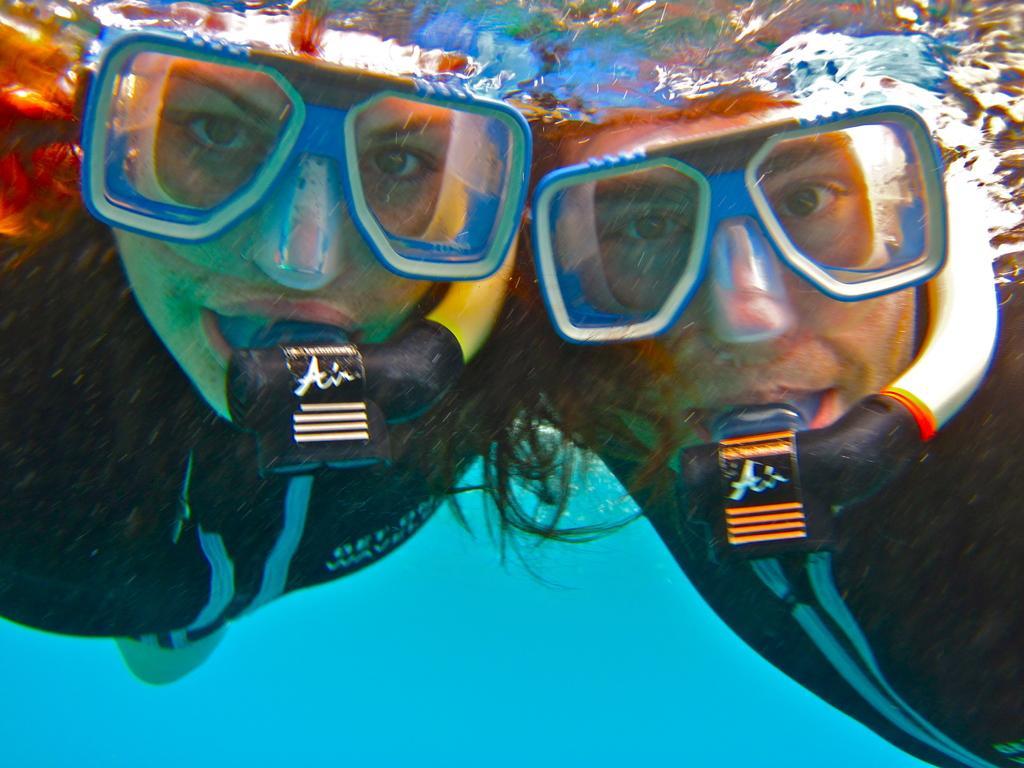How would you summarize this image in a sentence or two? In the picture I can see a man and a woman are in the water. They are wearing some objects. The background of the image is blue in color. 